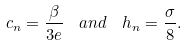<formula> <loc_0><loc_0><loc_500><loc_500>c _ { n } = \frac { \beta } { 3 e } \ \ a n d \ \ h _ { n } = \frac { \sigma } { 8 } .</formula> 